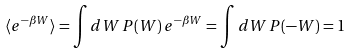<formula> <loc_0><loc_0><loc_500><loc_500>\langle e ^ { - \beta W } \rangle = \int d W \, P ( W ) \, e ^ { - \beta W } = \int d W \, P ( - W ) = 1</formula> 